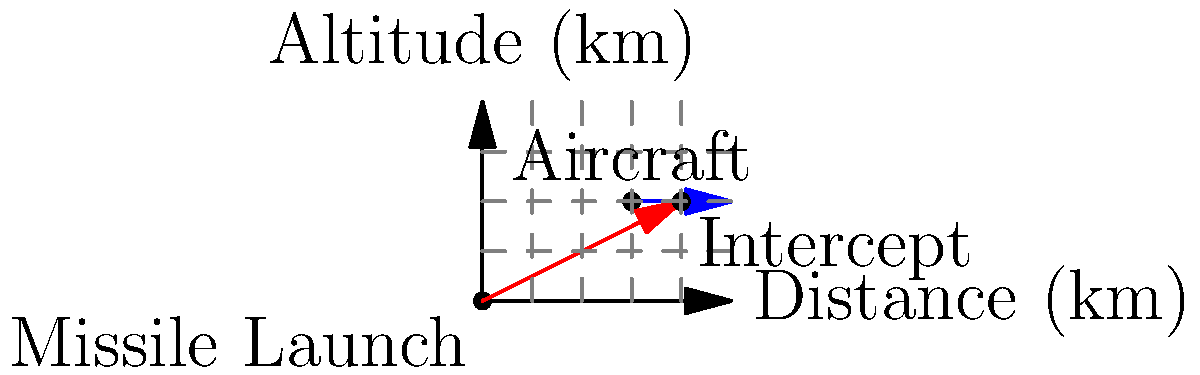A surface-to-air missile is launched to intercept an aircraft flying at a constant altitude of 40 km. The aircraft is initially detected 60 km away from the launch site and is moving away at a speed of 1000 km/h. The missile travels at a constant speed of 4000 km/h. Assuming the missile follows a straight path, at what distance from the launch site will the interception occur? Let's approach this step-by-step:

1) First, we need to determine the time it takes for the interception to occur. Let's call this time $t$.

2) The missile's distance traveled can be expressed as: $d_m = 4000t$

3) The aircraft's distance from the launch site at time $t$ can be expressed as: $d_a = 60 + 1000t$

4) At the point of interception, these distances will be equal:

   $4000t = 60 + 1000t$

5) Solving this equation:
   
   $3000t = 60$
   $t = 60/3000 = 1/50$ hours, or 72 seconds

6) Now that we know the time, we can calculate the distance:

   $d = 4000 * (1/50) = 80$ km

Therefore, the interception will occur 80 km from the launch site.

This matches with our diagram, where we can see the intercept point at 80 km on the x-axis.
Answer: 80 km 